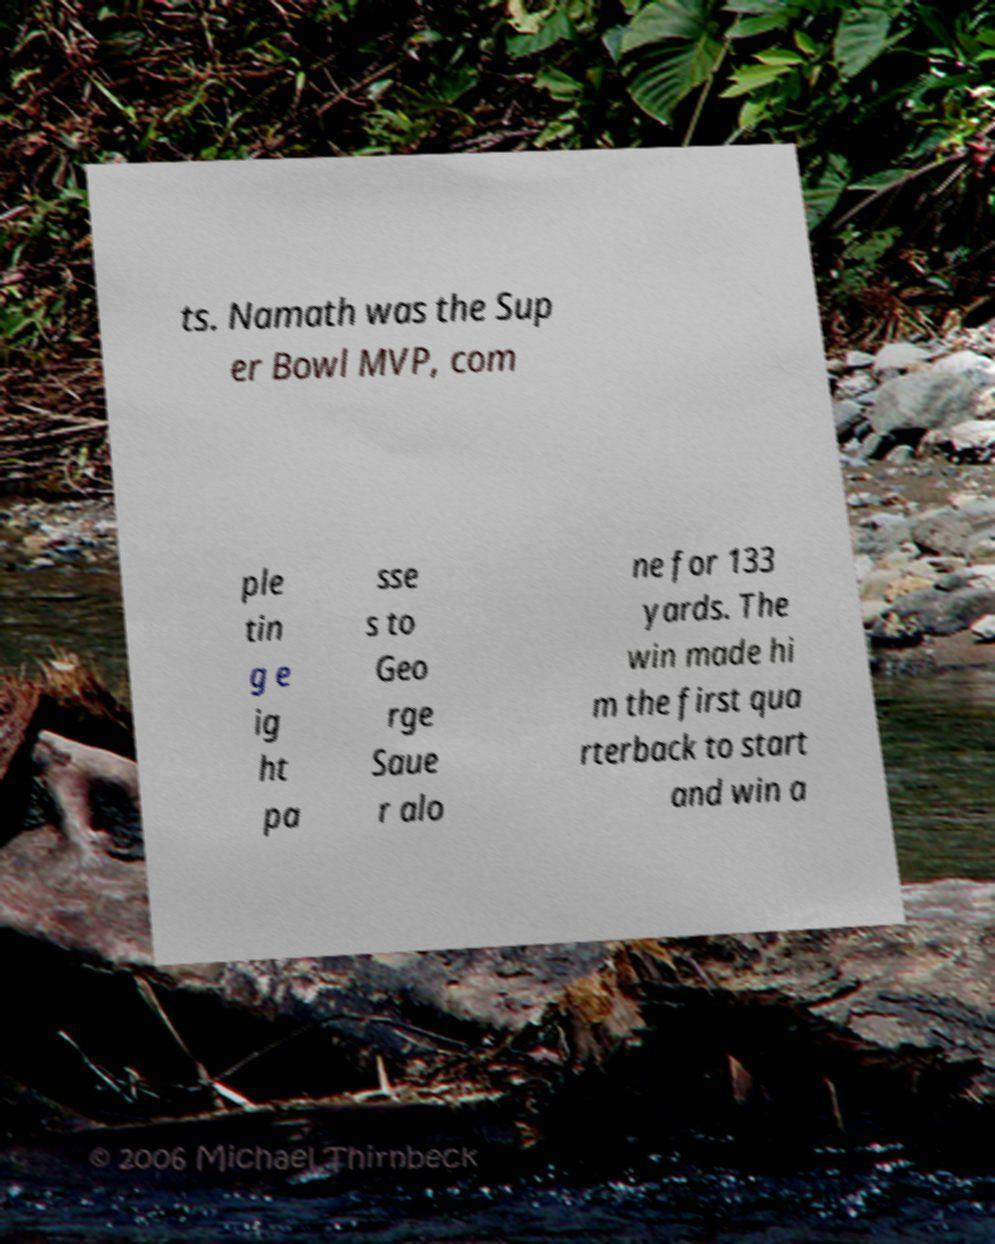Can you accurately transcribe the text from the provided image for me? ts. Namath was the Sup er Bowl MVP, com ple tin g e ig ht pa sse s to Geo rge Saue r alo ne for 133 yards. The win made hi m the first qua rterback to start and win a 